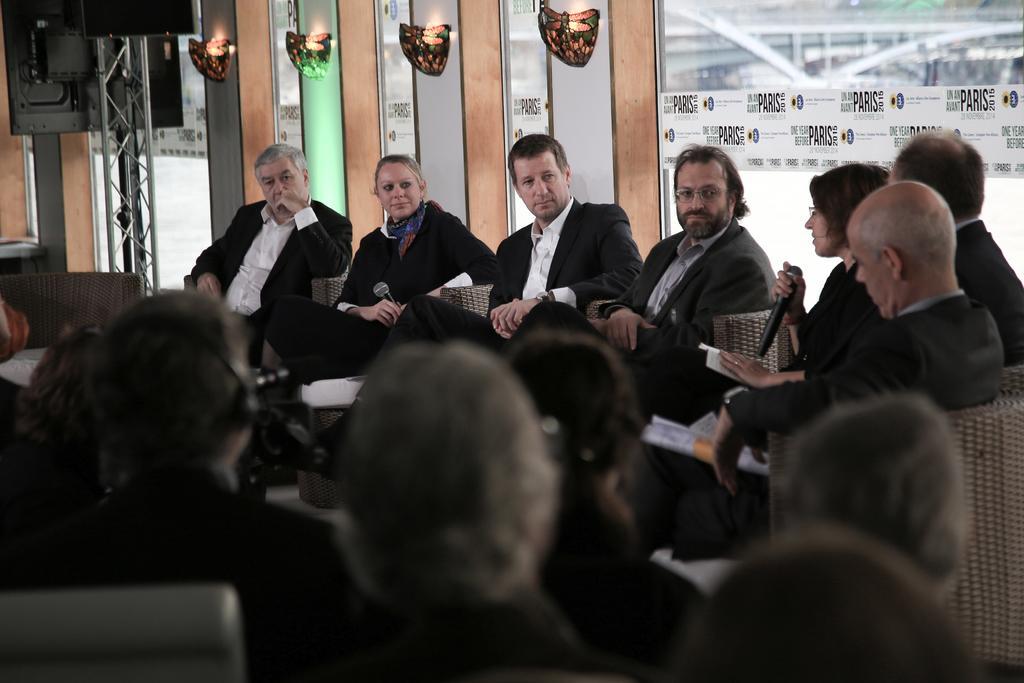How would you summarize this image in a sentence or two? In this image, we can see people sitting on the chairs and there are wearing coats and some are holding objects. In the background, there are lights and we can see papers with some text are pasted on the glass doors and there is a television with a stand. 